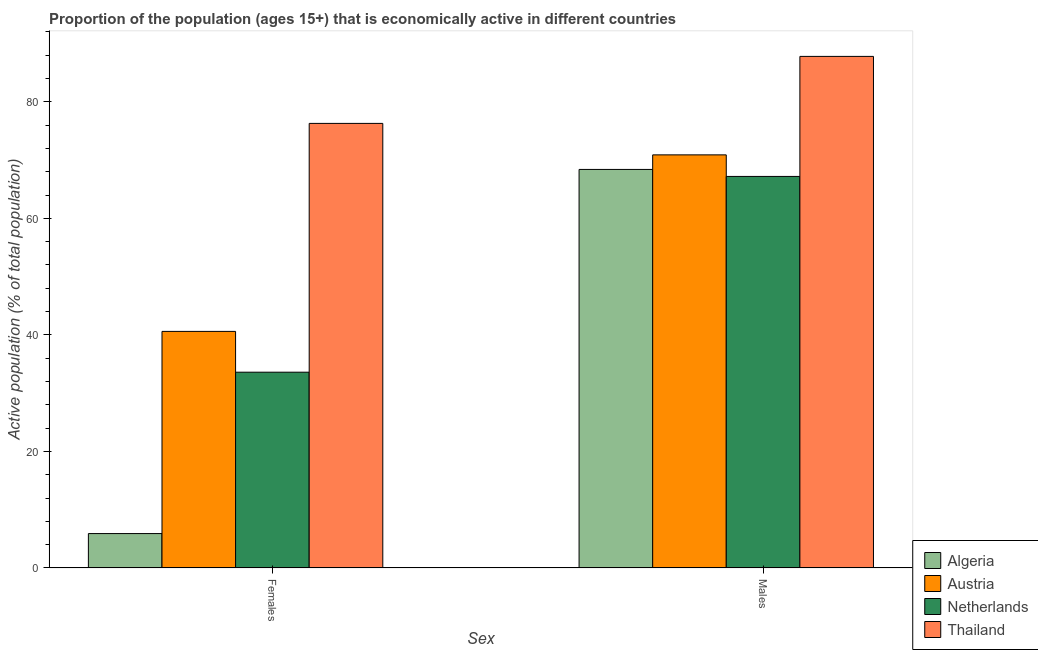How many bars are there on the 1st tick from the left?
Keep it short and to the point. 4. How many bars are there on the 1st tick from the right?
Give a very brief answer. 4. What is the label of the 1st group of bars from the left?
Your response must be concise. Females. What is the percentage of economically active female population in Algeria?
Ensure brevity in your answer.  5.9. Across all countries, what is the maximum percentage of economically active male population?
Make the answer very short. 87.8. Across all countries, what is the minimum percentage of economically active male population?
Offer a terse response. 67.2. In which country was the percentage of economically active female population maximum?
Make the answer very short. Thailand. In which country was the percentage of economically active male population minimum?
Make the answer very short. Netherlands. What is the total percentage of economically active male population in the graph?
Offer a very short reply. 294.3. What is the difference between the percentage of economically active male population in Netherlands and that in Austria?
Your answer should be very brief. -3.7. What is the difference between the percentage of economically active male population in Netherlands and the percentage of economically active female population in Thailand?
Offer a very short reply. -9.1. What is the average percentage of economically active male population per country?
Provide a short and direct response. 73.58. What is the difference between the percentage of economically active female population and percentage of economically active male population in Netherlands?
Provide a succinct answer. -33.6. What is the ratio of the percentage of economically active female population in Austria to that in Netherlands?
Offer a very short reply. 1.21. Is the percentage of economically active male population in Austria less than that in Thailand?
Ensure brevity in your answer.  Yes. Are all the bars in the graph horizontal?
Give a very brief answer. No. How many countries are there in the graph?
Offer a terse response. 4. What is the difference between two consecutive major ticks on the Y-axis?
Your answer should be very brief. 20. Does the graph contain any zero values?
Your answer should be very brief. No. What is the title of the graph?
Make the answer very short. Proportion of the population (ages 15+) that is economically active in different countries. What is the label or title of the X-axis?
Make the answer very short. Sex. What is the label or title of the Y-axis?
Your answer should be compact. Active population (% of total population). What is the Active population (% of total population) of Algeria in Females?
Your answer should be compact. 5.9. What is the Active population (% of total population) in Austria in Females?
Provide a succinct answer. 40.6. What is the Active population (% of total population) in Netherlands in Females?
Keep it short and to the point. 33.6. What is the Active population (% of total population) in Thailand in Females?
Your answer should be compact. 76.3. What is the Active population (% of total population) of Algeria in Males?
Your answer should be very brief. 68.4. What is the Active population (% of total population) in Austria in Males?
Make the answer very short. 70.9. What is the Active population (% of total population) of Netherlands in Males?
Provide a short and direct response. 67.2. What is the Active population (% of total population) in Thailand in Males?
Provide a short and direct response. 87.8. Across all Sex, what is the maximum Active population (% of total population) of Algeria?
Keep it short and to the point. 68.4. Across all Sex, what is the maximum Active population (% of total population) in Austria?
Your answer should be compact. 70.9. Across all Sex, what is the maximum Active population (% of total population) in Netherlands?
Your answer should be compact. 67.2. Across all Sex, what is the maximum Active population (% of total population) of Thailand?
Ensure brevity in your answer.  87.8. Across all Sex, what is the minimum Active population (% of total population) in Algeria?
Your answer should be compact. 5.9. Across all Sex, what is the minimum Active population (% of total population) of Austria?
Offer a very short reply. 40.6. Across all Sex, what is the minimum Active population (% of total population) of Netherlands?
Provide a short and direct response. 33.6. Across all Sex, what is the minimum Active population (% of total population) in Thailand?
Give a very brief answer. 76.3. What is the total Active population (% of total population) of Algeria in the graph?
Provide a succinct answer. 74.3. What is the total Active population (% of total population) in Austria in the graph?
Offer a very short reply. 111.5. What is the total Active population (% of total population) in Netherlands in the graph?
Ensure brevity in your answer.  100.8. What is the total Active population (% of total population) in Thailand in the graph?
Ensure brevity in your answer.  164.1. What is the difference between the Active population (% of total population) in Algeria in Females and that in Males?
Offer a very short reply. -62.5. What is the difference between the Active population (% of total population) of Austria in Females and that in Males?
Your answer should be compact. -30.3. What is the difference between the Active population (% of total population) in Netherlands in Females and that in Males?
Make the answer very short. -33.6. What is the difference between the Active population (% of total population) of Algeria in Females and the Active population (% of total population) of Austria in Males?
Provide a short and direct response. -65. What is the difference between the Active population (% of total population) in Algeria in Females and the Active population (% of total population) in Netherlands in Males?
Offer a terse response. -61.3. What is the difference between the Active population (% of total population) in Algeria in Females and the Active population (% of total population) in Thailand in Males?
Your answer should be very brief. -81.9. What is the difference between the Active population (% of total population) of Austria in Females and the Active population (% of total population) of Netherlands in Males?
Your answer should be very brief. -26.6. What is the difference between the Active population (% of total population) of Austria in Females and the Active population (% of total population) of Thailand in Males?
Make the answer very short. -47.2. What is the difference between the Active population (% of total population) of Netherlands in Females and the Active population (% of total population) of Thailand in Males?
Offer a very short reply. -54.2. What is the average Active population (% of total population) of Algeria per Sex?
Provide a short and direct response. 37.15. What is the average Active population (% of total population) in Austria per Sex?
Provide a succinct answer. 55.75. What is the average Active population (% of total population) in Netherlands per Sex?
Provide a succinct answer. 50.4. What is the average Active population (% of total population) in Thailand per Sex?
Offer a very short reply. 82.05. What is the difference between the Active population (% of total population) of Algeria and Active population (% of total population) of Austria in Females?
Ensure brevity in your answer.  -34.7. What is the difference between the Active population (% of total population) of Algeria and Active population (% of total population) of Netherlands in Females?
Ensure brevity in your answer.  -27.7. What is the difference between the Active population (% of total population) of Algeria and Active population (% of total population) of Thailand in Females?
Give a very brief answer. -70.4. What is the difference between the Active population (% of total population) in Austria and Active population (% of total population) in Netherlands in Females?
Give a very brief answer. 7. What is the difference between the Active population (% of total population) of Austria and Active population (% of total population) of Thailand in Females?
Offer a very short reply. -35.7. What is the difference between the Active population (% of total population) in Netherlands and Active population (% of total population) in Thailand in Females?
Your answer should be compact. -42.7. What is the difference between the Active population (% of total population) in Algeria and Active population (% of total population) in Thailand in Males?
Provide a succinct answer. -19.4. What is the difference between the Active population (% of total population) of Austria and Active population (% of total population) of Netherlands in Males?
Your response must be concise. 3.7. What is the difference between the Active population (% of total population) of Austria and Active population (% of total population) of Thailand in Males?
Offer a terse response. -16.9. What is the difference between the Active population (% of total population) in Netherlands and Active population (% of total population) in Thailand in Males?
Make the answer very short. -20.6. What is the ratio of the Active population (% of total population) of Algeria in Females to that in Males?
Provide a succinct answer. 0.09. What is the ratio of the Active population (% of total population) in Austria in Females to that in Males?
Offer a very short reply. 0.57. What is the ratio of the Active population (% of total population) of Netherlands in Females to that in Males?
Make the answer very short. 0.5. What is the ratio of the Active population (% of total population) in Thailand in Females to that in Males?
Offer a very short reply. 0.87. What is the difference between the highest and the second highest Active population (% of total population) of Algeria?
Your answer should be very brief. 62.5. What is the difference between the highest and the second highest Active population (% of total population) in Austria?
Give a very brief answer. 30.3. What is the difference between the highest and the second highest Active population (% of total population) in Netherlands?
Offer a terse response. 33.6. What is the difference between the highest and the second highest Active population (% of total population) in Thailand?
Ensure brevity in your answer.  11.5. What is the difference between the highest and the lowest Active population (% of total population) in Algeria?
Keep it short and to the point. 62.5. What is the difference between the highest and the lowest Active population (% of total population) in Austria?
Your response must be concise. 30.3. What is the difference between the highest and the lowest Active population (% of total population) of Netherlands?
Provide a succinct answer. 33.6. What is the difference between the highest and the lowest Active population (% of total population) of Thailand?
Your response must be concise. 11.5. 